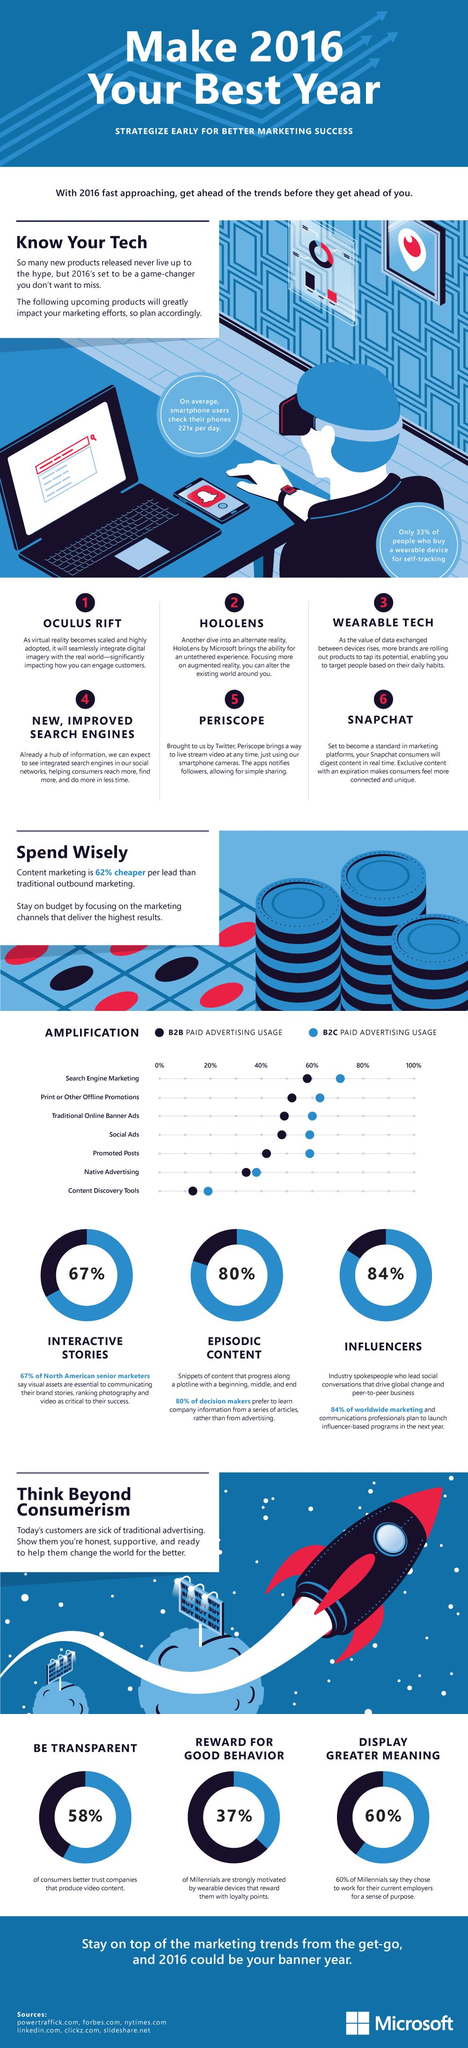Give some essential details in this illustration. Periscope can be used to livestream videos. Native advertising, in which usage by both B2B and B2C is nearly the same, is a type of paid advertising where the ad content blends in with the platform's regular content. According to a study, 70% of B2C businesses use paid advertising as a part of their search engine marketing strategy. A recent survey has revealed that 37% of millennials are motivated by wearable devices that reward them with loyalty points. Consumers expect transparency, rewards for good behavior, and greater meaning to be displayed by our company and its products. 